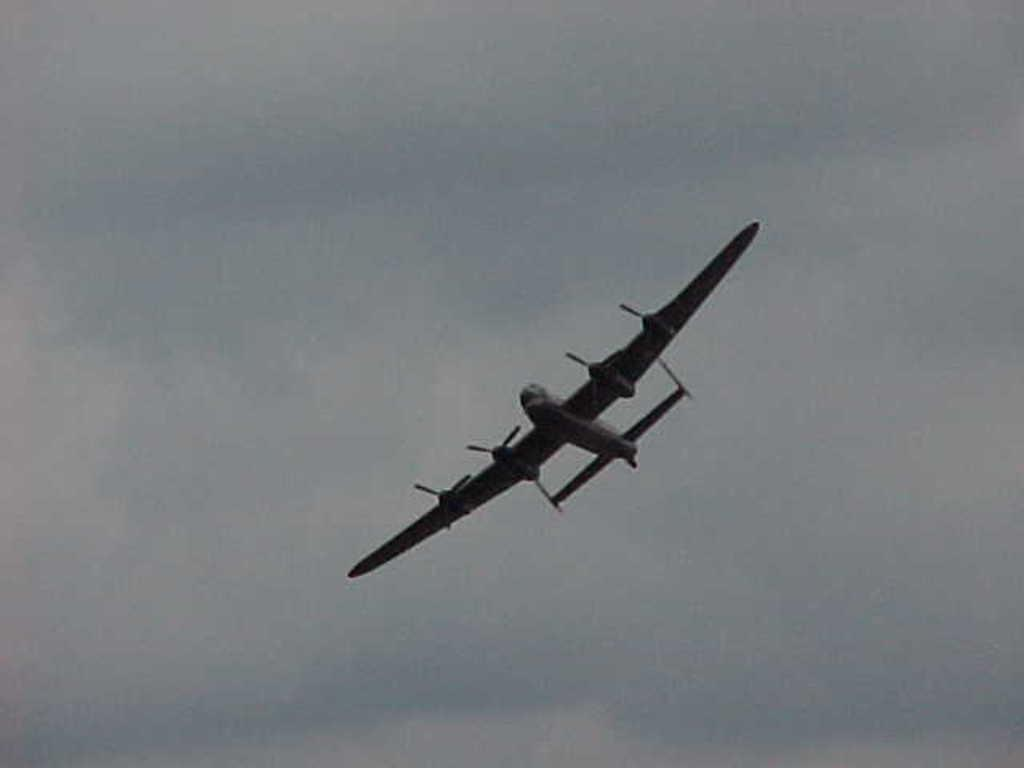What is the main subject of the image? The main subject of the image is an aircraft. What is the aircraft doing in the image? The aircraft is flying in the air. What can be seen in the background of the image? The sky is visible in the background of the image. What is the condition of the sky in the image? Clouds are present in the sky. What type of drain can be seen on the aircraft in the image? There is no drain present on the aircraft in the image. How many blades are visible on the aircraft in the image? The image does not show any blades on the aircraft. 